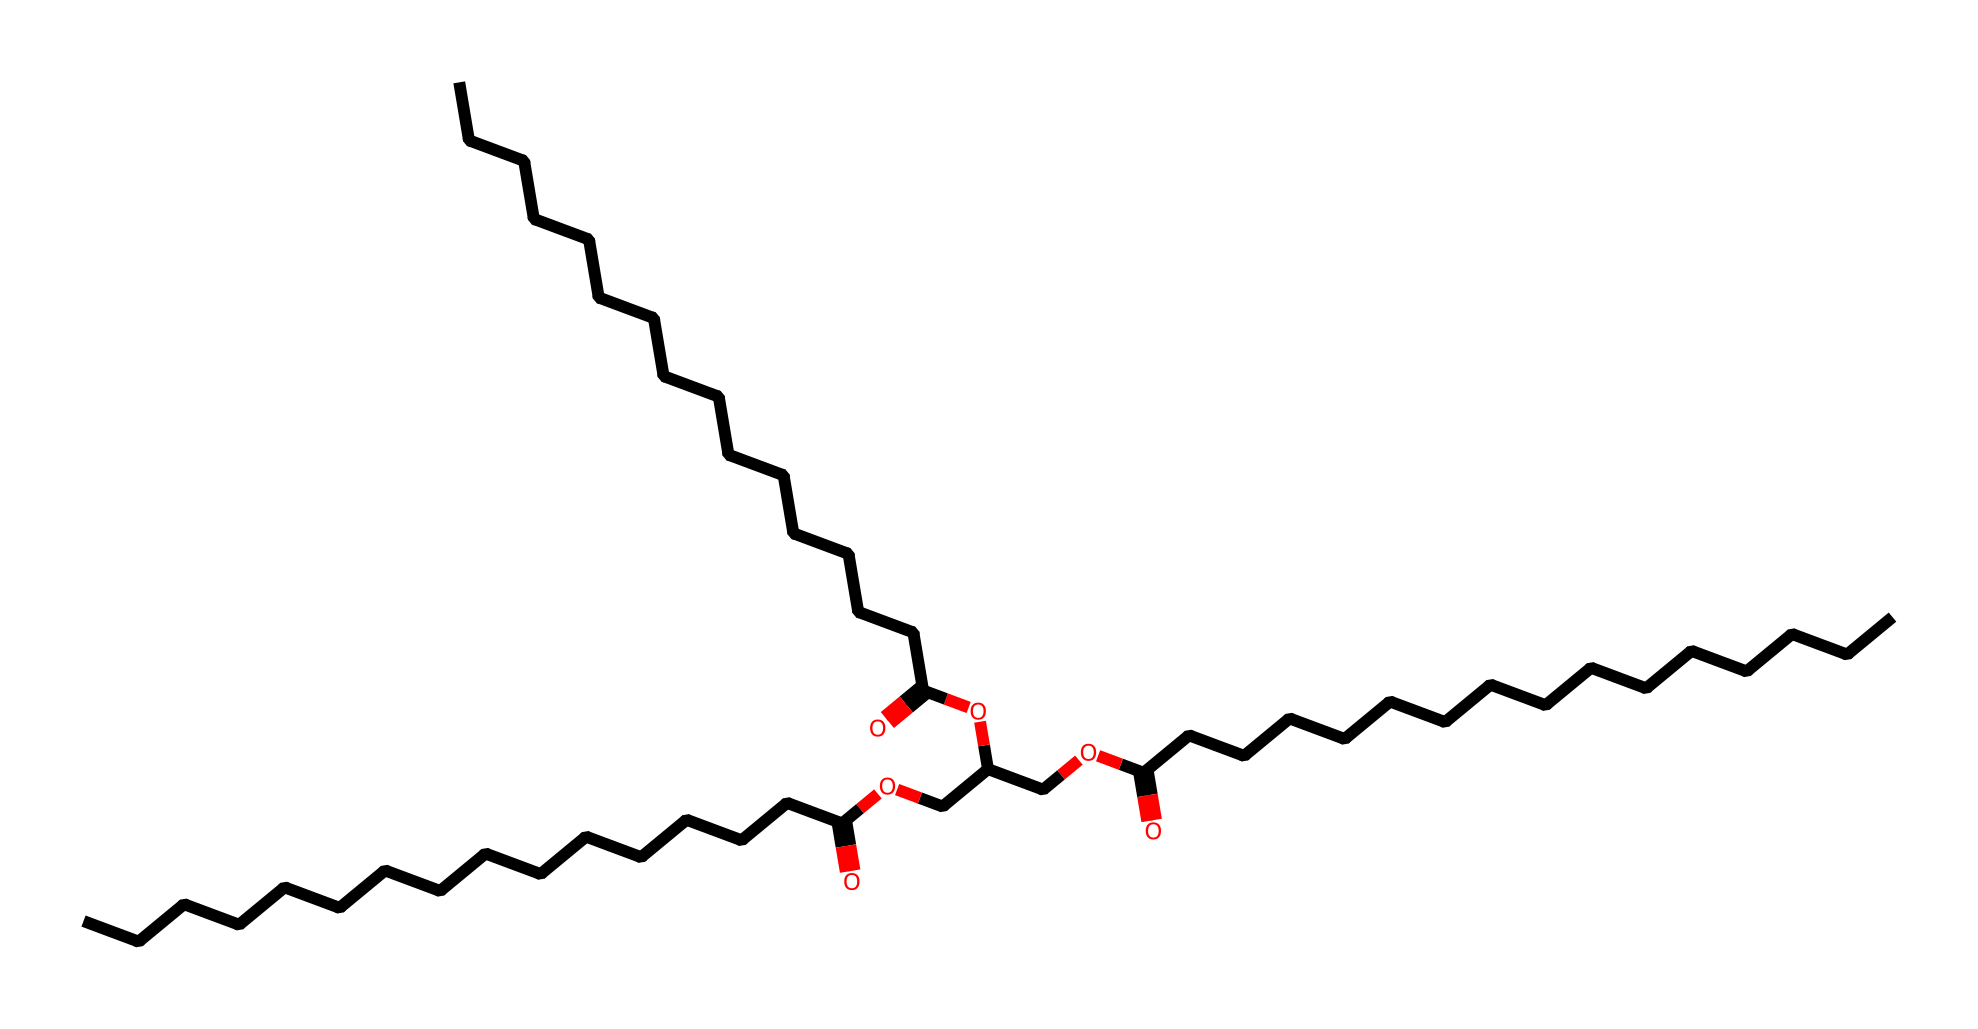How many carbon atoms are present in this structure? The SMILES representation indicates a long carbon chain. By counting the 'C' occurrences in the structure, I find that there are 30 carbon atoms in total.
Answer: 30 What functional groups are present in this chemical? Analyzing the SMILES, I identify carboxylic acid functional groups (indicated by '=O' and 'O') and ester groups (based on the structure with oxygen between carbon chains).
Answer: carboxylic acid and ester What is the total number of oxygen atoms in the structure? By counting the instances of 'O' in the SMILES representation, I see there are 6 oxygen atoms in total.
Answer: 6 Is this lubricant likely to be biodegradable? Given that the lubricant is plant-based, and contains natural esters and acids, it is reasonable to infer that the compound is biodegradable.
Answer: yes What type of lubrication properties might this compound provide? The structure indicates a compound with a long carbon chain, which typically relates to good viscosity and film strength; thus, it will likely provide excellent lubricating properties.
Answer: excellent lubrication What is the primary purpose of using this type of lubricant in firearms maintenance? The long-chain structure suggests a stable and non-corrosive product, essential for protecting and maintaining the moving parts of firearms, which addresses the need for conservation efforts.
Answer: protection against corrosion 